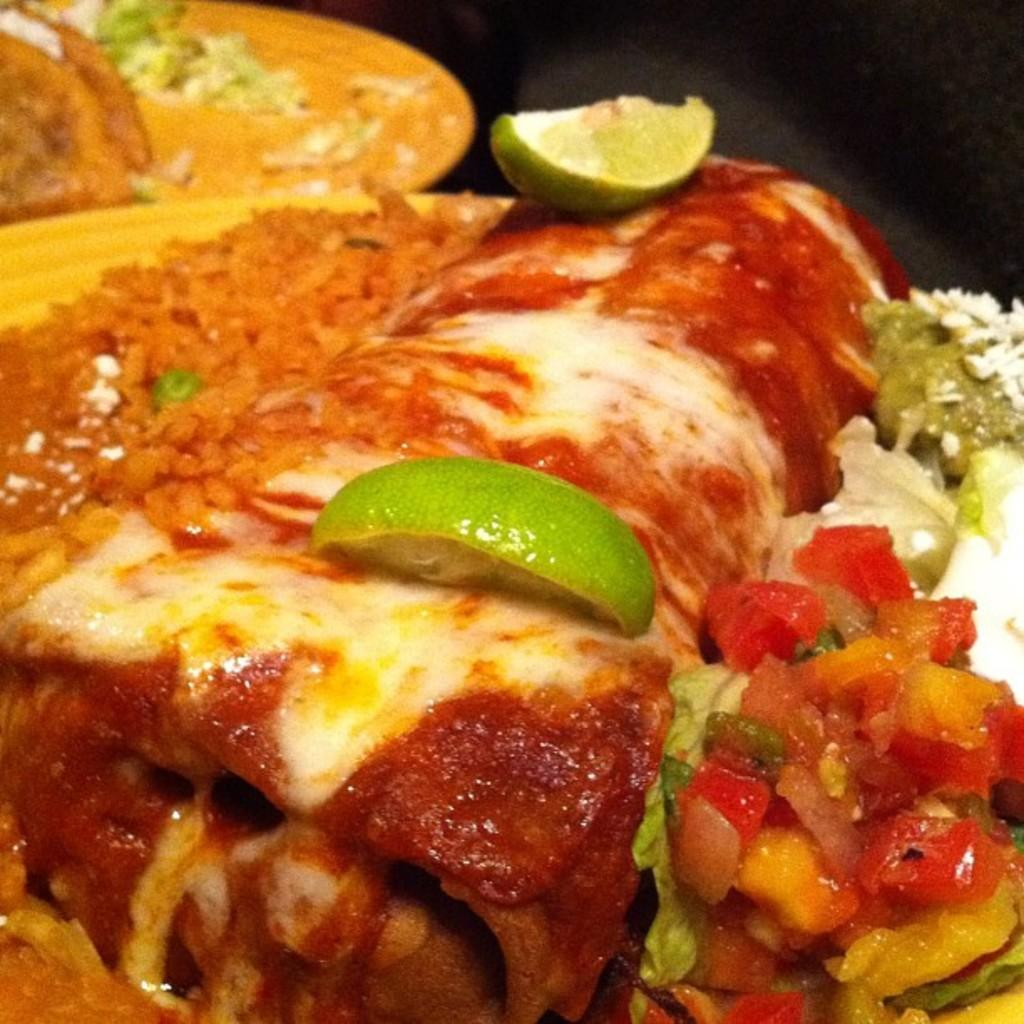What is the main subject of the image? The main subject of the image is a close view of a food item. Can you describe any specific details about the food item? Unfortunately, the provided facts do not give any specific details about the food item. Is there any part of the image that is dark? Yes, the image has a dark part. What type of science experiment is being conducted with the powder in the image? There is no powder or science experiment present in the image. Where is the mailbox located in the image? There is no mailbox present in the image. 